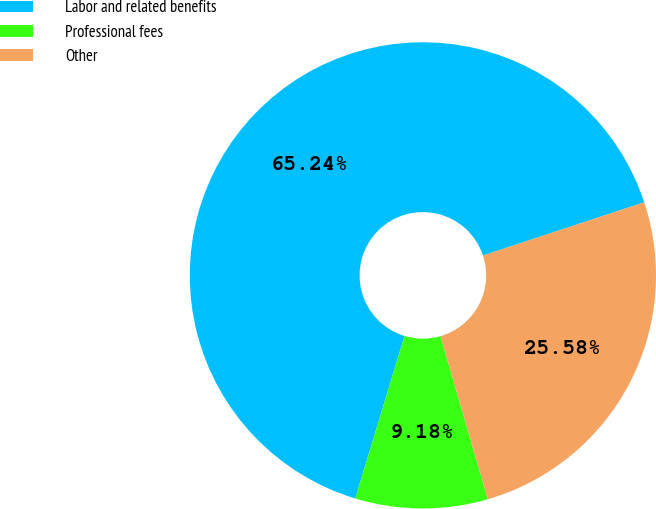Convert chart to OTSL. <chart><loc_0><loc_0><loc_500><loc_500><pie_chart><fcel>Labor and related benefits<fcel>Professional fees<fcel>Other<nl><fcel>65.24%<fcel>9.18%<fcel>25.58%<nl></chart> 